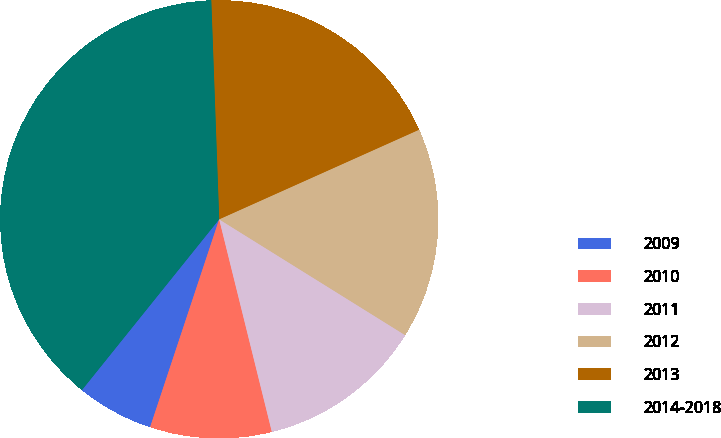<chart> <loc_0><loc_0><loc_500><loc_500><pie_chart><fcel>2009<fcel>2010<fcel>2011<fcel>2012<fcel>2013<fcel>2014-2018<nl><fcel>5.67%<fcel>8.97%<fcel>12.27%<fcel>15.57%<fcel>18.87%<fcel>38.65%<nl></chart> 